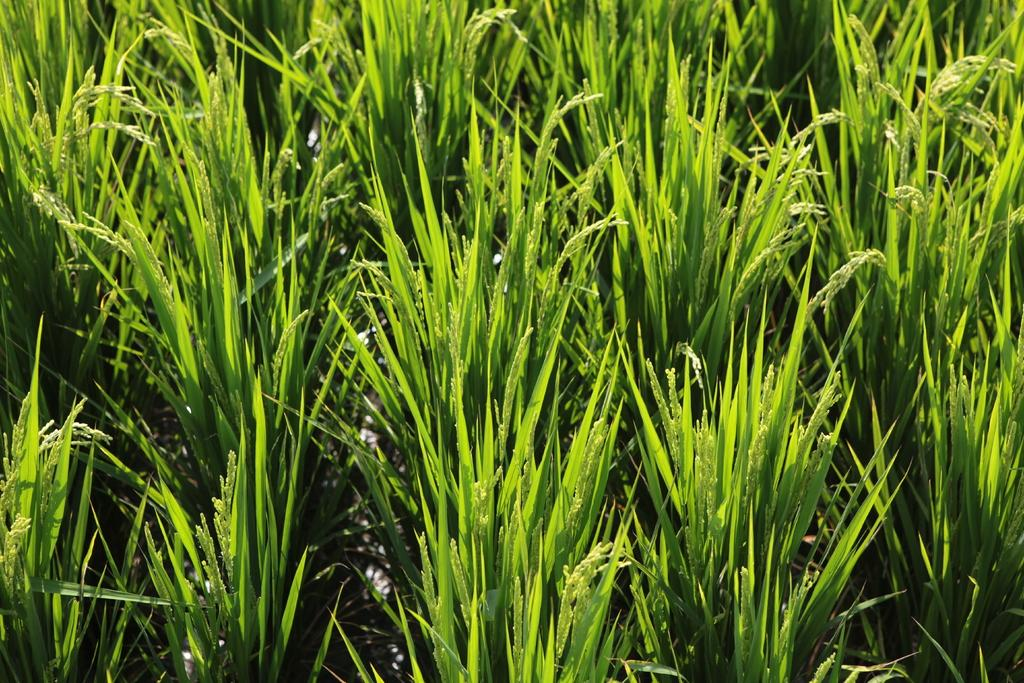What type of vegetation can be seen in the image? There is grass in the image. What color is the grass in the image? The grass is green in color. Where is the kettle located in the image? There is no kettle present in the image. What type of plantation can be seen in the image? There is no plantation present in the image; it only features grass. 